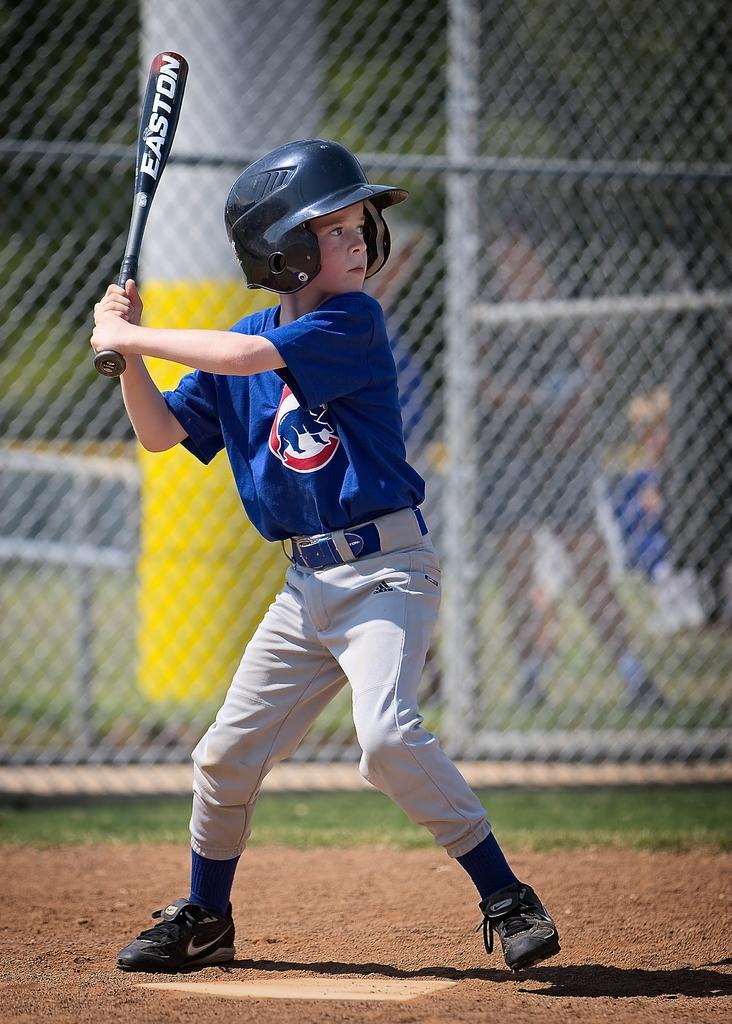How would you summarize this image in a sentence or two? In the picture we can see a kid wearing blue color T-shirt, white color pant, black color shoes, helmet and holding baseball stick in his hands and in the background of the picture there is net and we can see some persons standing. 